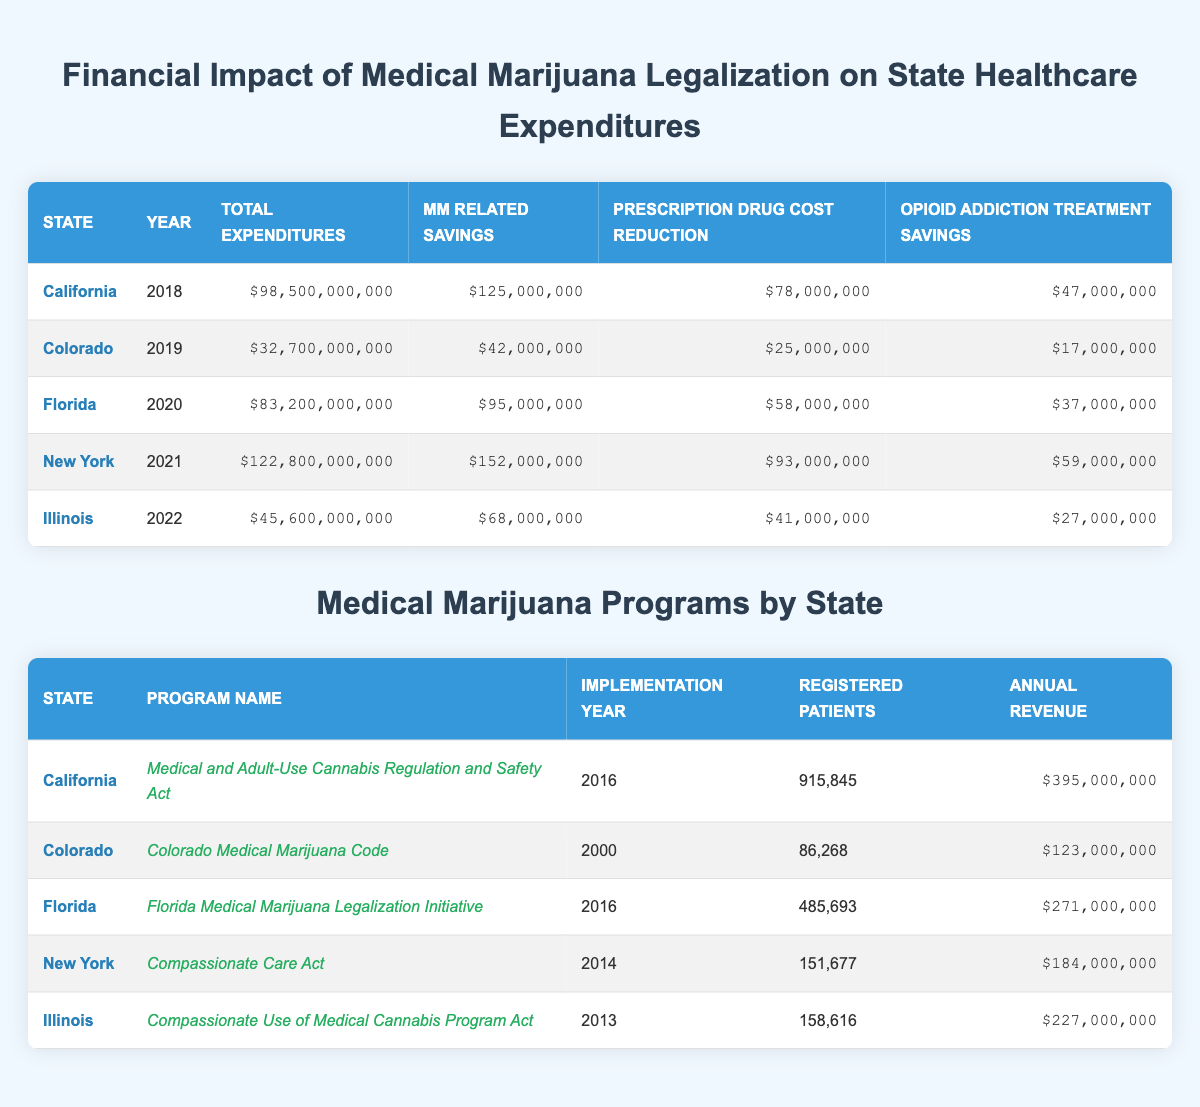What was the total healthcare expenditure for California in 2018? Referring to the table under the California row in 2018, the total expenditures listed is $98,500,000,000.
Answer: $98,500,000,000 How much did Colorado save on medical marijuana-related costs in 2019? Looking at the row for Colorado in 2019, the medical marijuana-related savings reported is $42,000,000.
Answer: $42,000,000 Which state had the highest total healthcare expenditures and what was the amount? By reviewing the total expenditures column for each state, New York in 2021 had the highest total expenditures at $122,800,000,000.
Answer: New York; $122,800,000,000 What is the total savings from prescription drug cost reductions across all states? Summing the prescription drug cost reductions from all states: $78,000,000 (California) + $25,000,000 (Colorado) + $58,000,000 (Florida) + $93,000,000 (New York) + $41,000,000 (Illinois) = $295,000,000.
Answer: $295,000,000 Did Florida have medical marijuana savings greater than Illinois in 2020? Comparing the two values, Florida's medical marijuana-related savings was $95,000,000, while Illinois had $68,000,000. Therefore, Florida's savings were greater than Illinois's.
Answer: Yes What is the average annual revenue generated by the medical marijuana programs across these five states? Adding up the annual revenue for all states: $395,000,000 (California) + $123,000,000 (Colorado) + $271,000,000 (Florida) + $184,000,000 (New York) + $227,000,000 (Illinois) = $1,300,000,000. There are 5 states, so the average is $1,300,000,000 / 5 = $260,000,000.
Answer: $260,000,000 Is it true that the opioid addiction treatment savings in New York were higher than those in Colorado? Opioid addiction treatment savings for New York were $59,000,000 and for Colorado were $17,000,000. Since $59,000,000 is greater, the statement is true.
Answer: Yes Which state reported the least amount of medical marijuana-related savings and what was that amount? From the savings data, Colorado in 2019 had the least amount of medical marijuana-related savings at $42,000,000.
Answer: Colorado; $42,000,000 Calculate the total of opioid addiction treatment savings compared to medical marijuana-related savings across all states. Adding the two categories separately: Total opioid addiction treatment savings = $47,000,000 (California) + $17,000,000 (Colorado) + $37,000,000 (Florida) + $59,000,000 (New York) + $27,000,000 (Illinois) = $187,000,000. Total medical marijuana-related savings = $125,000,000 + $42,000,000 + $95,000,000 + $152,000,000 + $68,000,000 = $482,000,000. Comparison shows significantly higher medical marijuana-related savings.
Answer: $482,000,000 (MM savings); $187,000,000 (Opioid savings) 